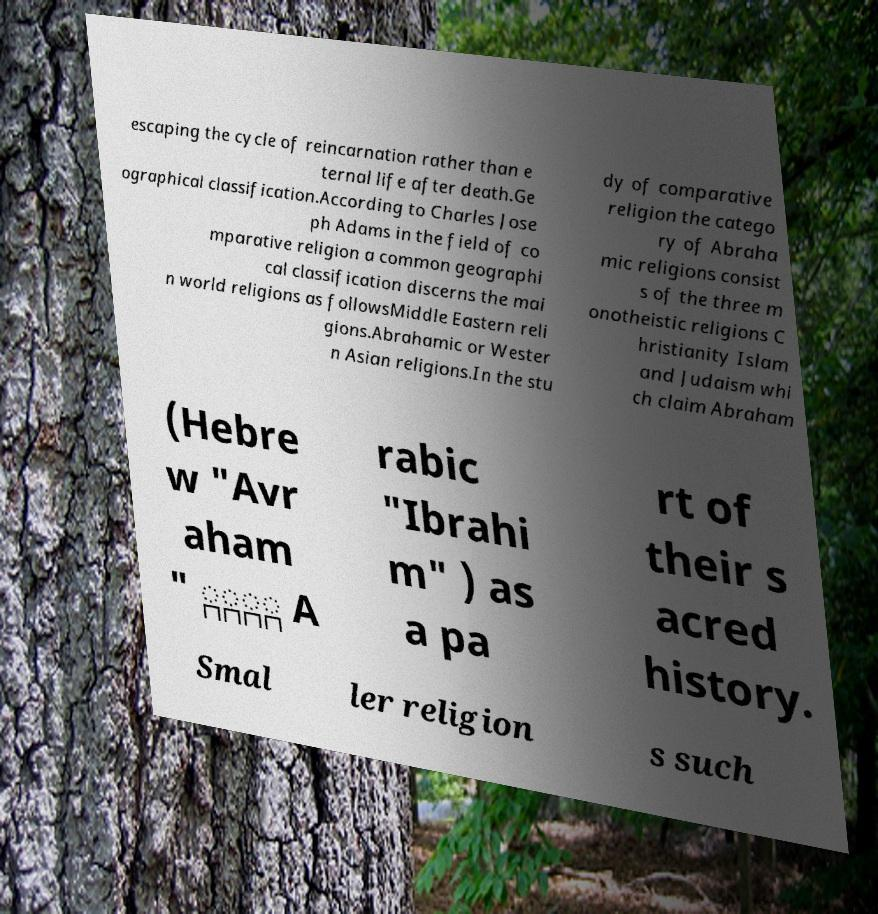Please identify and transcribe the text found in this image. escaping the cycle of reincarnation rather than e ternal life after death.Ge ographical classification.According to Charles Jose ph Adams in the field of co mparative religion a common geographi cal classification discerns the mai n world religions as followsMiddle Eastern reli gions.Abrahamic or Wester n Asian religions.In the stu dy of comparative religion the catego ry of Abraha mic religions consist s of the three m onotheistic religions C hristianity Islam and Judaism whi ch claim Abraham (Hebre w "Avr aham " ְַָָ A rabic "Ibrahi m" ) as a pa rt of their s acred history. Smal ler religion s such 